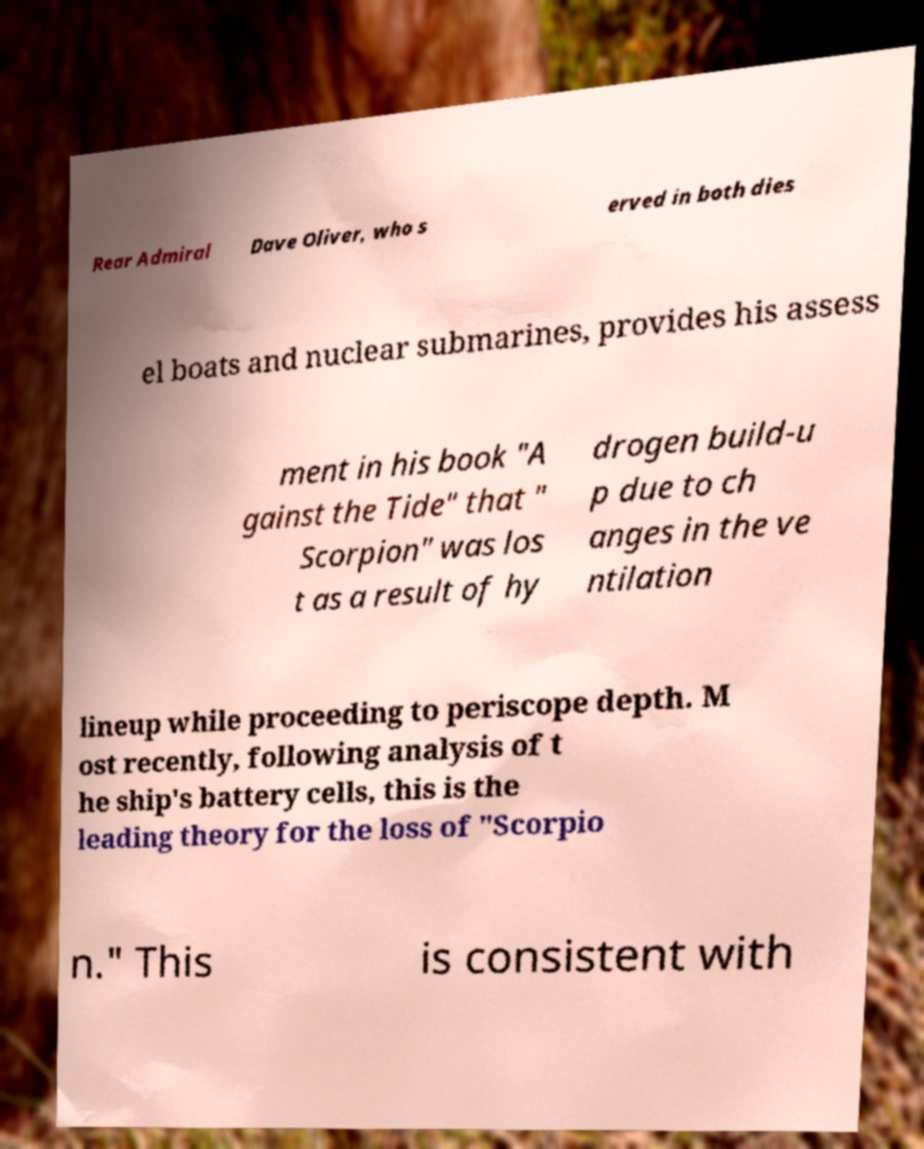I need the written content from this picture converted into text. Can you do that? Rear Admiral Dave Oliver, who s erved in both dies el boats and nuclear submarines, provides his assess ment in his book "A gainst the Tide" that " Scorpion" was los t as a result of hy drogen build-u p due to ch anges in the ve ntilation lineup while proceeding to periscope depth. M ost recently, following analysis of t he ship's battery cells, this is the leading theory for the loss of "Scorpio n." This is consistent with 